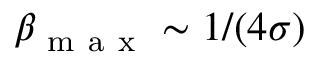<formula> <loc_0><loc_0><loc_500><loc_500>\beta _ { m a x } \sim 1 / ( 4 \sigma )</formula> 